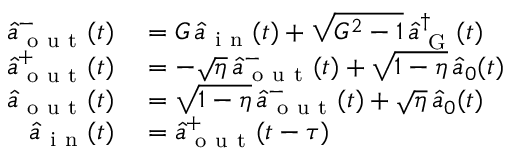Convert formula to latex. <formula><loc_0><loc_0><loc_500><loc_500>\begin{array} { r l } { \hat { a } _ { o u t } ^ { - } ( t ) } & = G \, \hat { a } _ { i n } ( t ) + \sqrt { G ^ { 2 } - 1 } \, \hat { a } _ { G } ^ { \dagger } ( t ) } \\ { \hat { a } _ { o u t } ^ { + } ( t ) } & = - \sqrt { \eta } \, \hat { a } _ { o u t } ^ { - } ( t ) + \sqrt { 1 - \eta } \, \hat { a } _ { 0 } ( t ) } \\ { \hat { a } _ { o u t } ( t ) } & = \sqrt { 1 - \eta } \, \hat { a } _ { o u t } ^ { - } ( t ) + \sqrt { \eta } \, \hat { a } _ { 0 } ( t ) } \\ { \hat { a } _ { i n } ( t ) } & = \hat { a } _ { o u t } ^ { + } ( t - \tau ) } \end{array}</formula> 